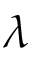Convert formula to latex. <formula><loc_0><loc_0><loc_500><loc_500>\lambda</formula> 